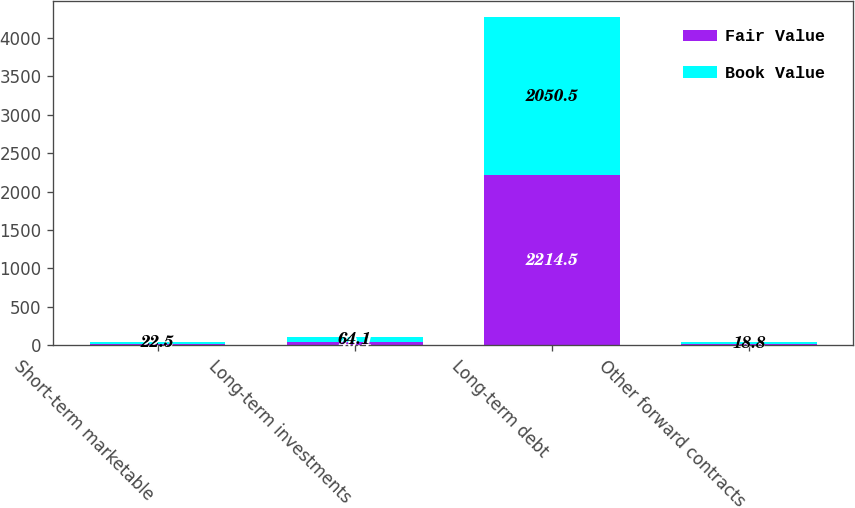<chart> <loc_0><loc_0><loc_500><loc_500><stacked_bar_chart><ecel><fcel>Short-term marketable<fcel>Long-term investments<fcel>Long-term debt<fcel>Other forward contracts<nl><fcel>Fair Value<fcel>22.5<fcel>40.4<fcel>2214.5<fcel>18.8<nl><fcel>Book Value<fcel>22.5<fcel>64.1<fcel>2050.5<fcel>18.8<nl></chart> 